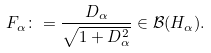Convert formula to latex. <formula><loc_0><loc_0><loc_500><loc_500>F _ { \alpha } \colon = \frac { D _ { \alpha } } { \sqrt { 1 + D _ { \alpha } ^ { 2 } } } \in \mathcal { B } ( H _ { \alpha } ) .</formula> 